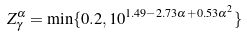Convert formula to latex. <formula><loc_0><loc_0><loc_500><loc_500>Z _ { \gamma } ^ { \alpha } = \min \{ 0 . 2 , 1 0 ^ { 1 . 4 9 - 2 . 7 3 \alpha + 0 . 5 3 \alpha ^ { 2 } } \}</formula> 